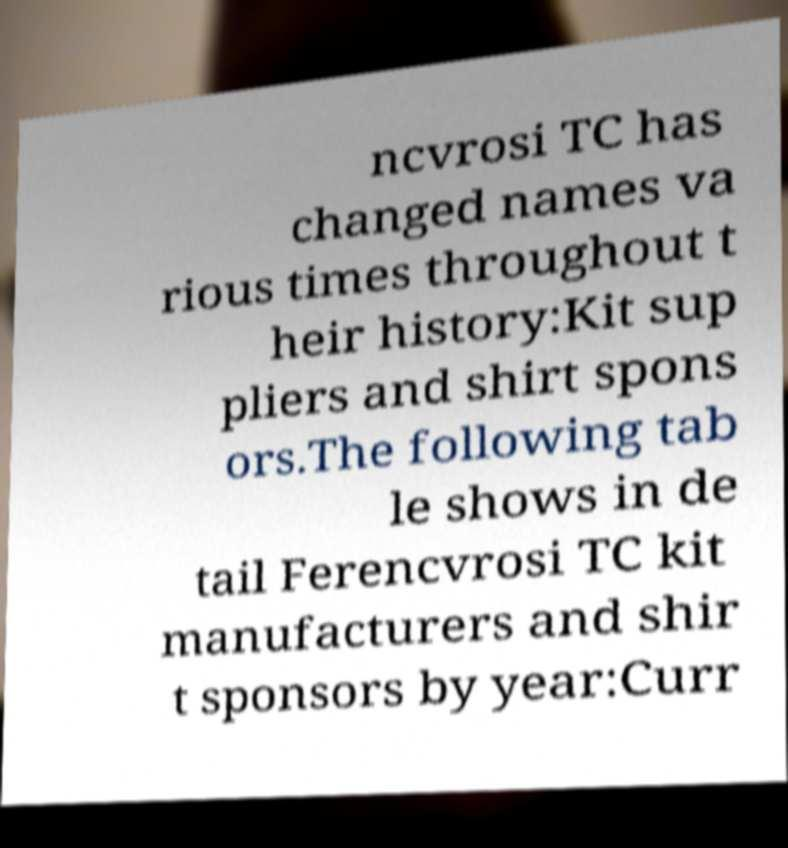I need the written content from this picture converted into text. Can you do that? ncvrosi TC has changed names va rious times throughout t heir history:Kit sup pliers and shirt spons ors.The following tab le shows in de tail Ferencvrosi TC kit manufacturers and shir t sponsors by year:Curr 